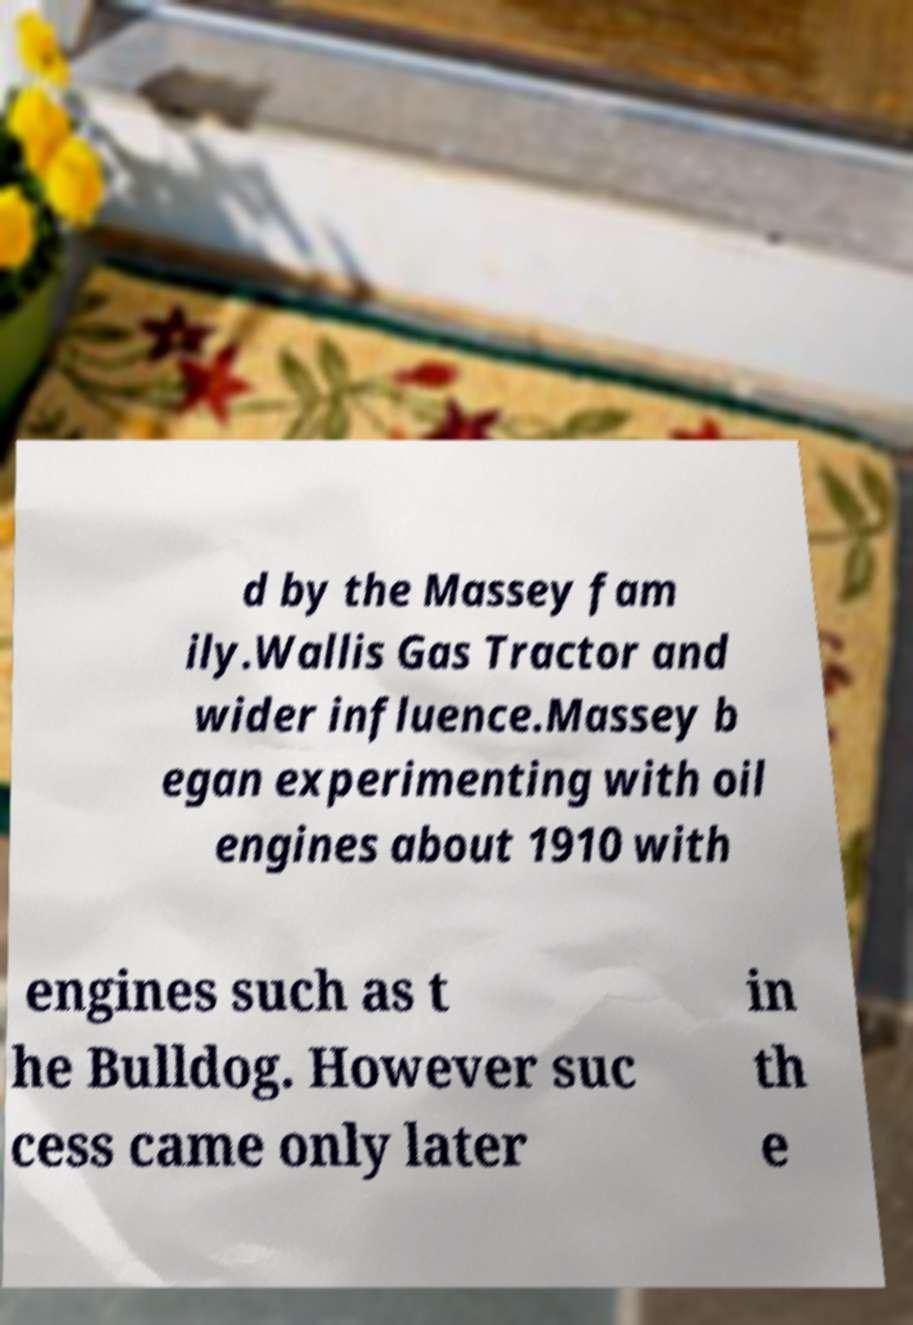Can you accurately transcribe the text from the provided image for me? d by the Massey fam ily.Wallis Gas Tractor and wider influence.Massey b egan experimenting with oil engines about 1910 with engines such as t he Bulldog. However suc cess came only later in th e 